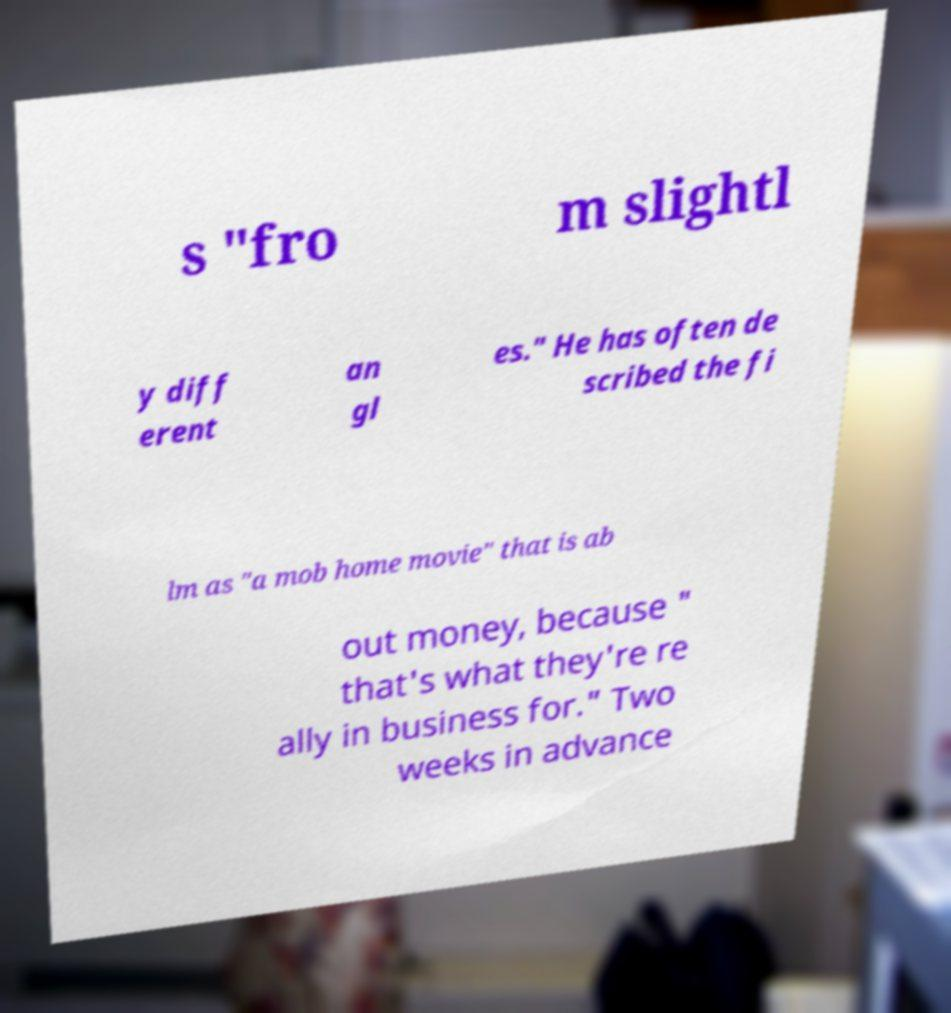What messages or text are displayed in this image? I need them in a readable, typed format. s "fro m slightl y diff erent an gl es." He has often de scribed the fi lm as "a mob home movie" that is ab out money, because " that's what they're re ally in business for." Two weeks in advance 